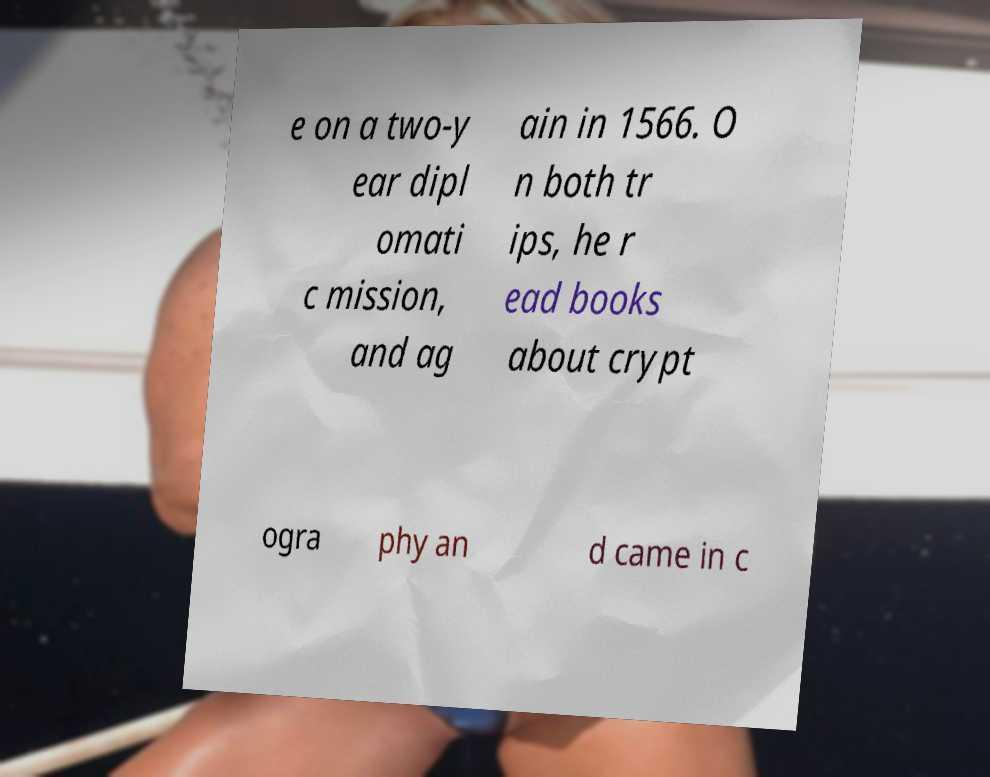Please identify and transcribe the text found in this image. e on a two-y ear dipl omati c mission, and ag ain in 1566. O n both tr ips, he r ead books about crypt ogra phy an d came in c 